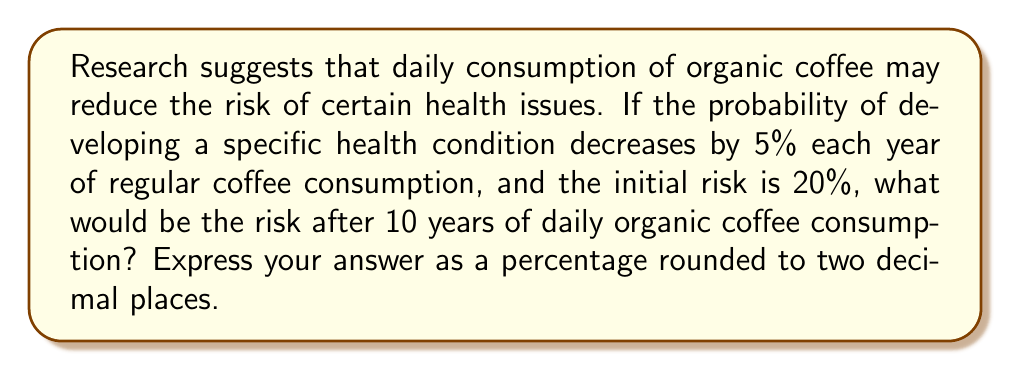Help me with this question. Let's approach this step-by-step using an exponential decay model:

1) Let $P(t)$ be the probability of developing the health condition after $t$ years.

2) The initial probability is 20%, so $P(0) = 0.20$.

3) The risk decreases by 5% each year, which means 95% of the risk remains. We can express this as a decimal: 0.95.

4) The exponential decay formula is:
   $P(t) = P(0) \cdot (1-r)^t$
   where $r$ is the rate of decrease (0.05 in this case).

5) Substituting our values:
   $P(10) = 0.20 \cdot (1-0.05)^{10}$
   $P(10) = 0.20 \cdot (0.95)^{10}$

6) Calculate:
   $P(10) = 0.20 \cdot 0.5987369392383789$
   $P(10) = 0.11974738784767578$

7) Convert to a percentage:
   $0.11974738784767578 \cdot 100\% = 11.97\%$

8) Rounding to two decimal places:
   $11.97\%$
Answer: 11.97% 